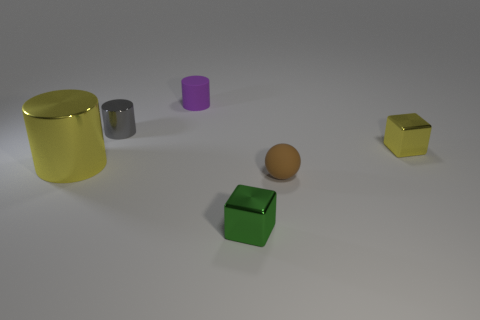Add 3 cyan metal cylinders. How many objects exist? 9 Subtract all cubes. How many objects are left? 4 Subtract 0 green balls. How many objects are left? 6 Subtract all yellow matte cylinders. Subtract all rubber balls. How many objects are left? 5 Add 2 tiny gray metallic things. How many tiny gray metallic things are left? 3 Add 2 small yellow rubber objects. How many small yellow rubber objects exist? 2 